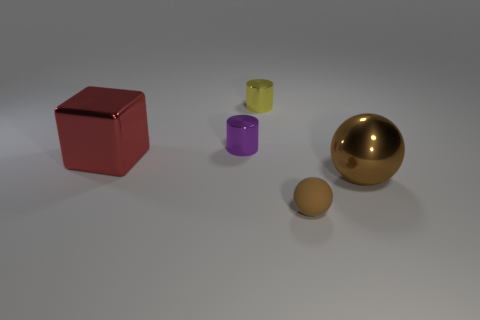There is a metallic cube; are there any brown matte balls behind it?
Make the answer very short. No. There is a sphere that is left of the shiny thing that is on the right side of the tiny brown matte ball; what color is it?
Give a very brief answer. Brown. Are there fewer tiny metallic cylinders than rubber things?
Ensure brevity in your answer.  No. How many other things have the same shape as the brown metal thing?
Keep it short and to the point. 1. The other rubber object that is the same size as the yellow thing is what color?
Your response must be concise. Brown. Is the number of small purple metal objects to the left of the purple cylinder the same as the number of small brown matte spheres that are behind the brown metal ball?
Make the answer very short. Yes. Are there any other purple rubber things of the same size as the purple thing?
Give a very brief answer. No. The purple cylinder is what size?
Your answer should be compact. Small. Are there the same number of small yellow metallic cylinders that are right of the tiny yellow shiny cylinder and tiny cubes?
Offer a terse response. Yes. How many other objects are the same color as the small rubber thing?
Your answer should be very brief. 1. 